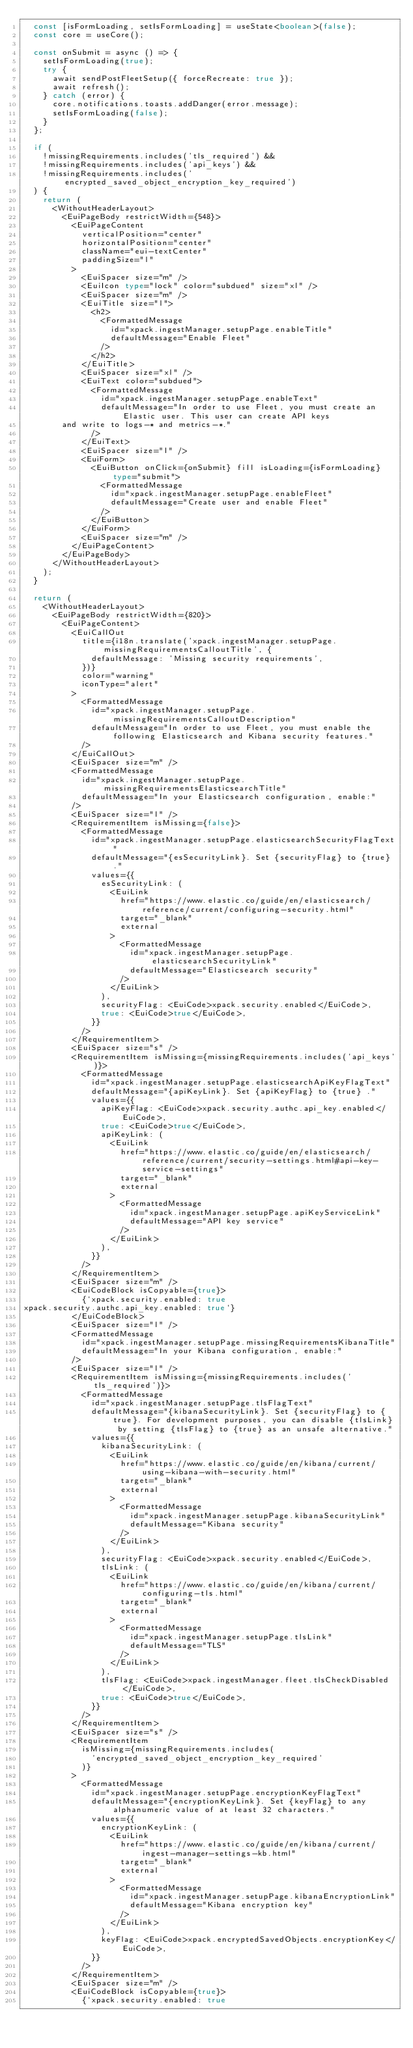<code> <loc_0><loc_0><loc_500><loc_500><_TypeScript_>  const [isFormLoading, setIsFormLoading] = useState<boolean>(false);
  const core = useCore();

  const onSubmit = async () => {
    setIsFormLoading(true);
    try {
      await sendPostFleetSetup({ forceRecreate: true });
      await refresh();
    } catch (error) {
      core.notifications.toasts.addDanger(error.message);
      setIsFormLoading(false);
    }
  };

  if (
    !missingRequirements.includes('tls_required') &&
    !missingRequirements.includes('api_keys') &&
    !missingRequirements.includes('encrypted_saved_object_encryption_key_required')
  ) {
    return (
      <WithoutHeaderLayout>
        <EuiPageBody restrictWidth={548}>
          <EuiPageContent
            verticalPosition="center"
            horizontalPosition="center"
            className="eui-textCenter"
            paddingSize="l"
          >
            <EuiSpacer size="m" />
            <EuiIcon type="lock" color="subdued" size="xl" />
            <EuiSpacer size="m" />
            <EuiTitle size="l">
              <h2>
                <FormattedMessage
                  id="xpack.ingestManager.setupPage.enableTitle"
                  defaultMessage="Enable Fleet"
                />
              </h2>
            </EuiTitle>
            <EuiSpacer size="xl" />
            <EuiText color="subdued">
              <FormattedMessage
                id="xpack.ingestManager.setupPage.enableText"
                defaultMessage="In order to use Fleet, you must create an Elastic user. This user can create API keys
        and write to logs-* and metrics-*."
              />
            </EuiText>
            <EuiSpacer size="l" />
            <EuiForm>
              <EuiButton onClick={onSubmit} fill isLoading={isFormLoading} type="submit">
                <FormattedMessage
                  id="xpack.ingestManager.setupPage.enableFleet"
                  defaultMessage="Create user and enable Fleet"
                />
              </EuiButton>
            </EuiForm>
            <EuiSpacer size="m" />
          </EuiPageContent>
        </EuiPageBody>
      </WithoutHeaderLayout>
    );
  }

  return (
    <WithoutHeaderLayout>
      <EuiPageBody restrictWidth={820}>
        <EuiPageContent>
          <EuiCallOut
            title={i18n.translate('xpack.ingestManager.setupPage.missingRequirementsCalloutTitle', {
              defaultMessage: 'Missing security requirements',
            })}
            color="warning"
            iconType="alert"
          >
            <FormattedMessage
              id="xpack.ingestManager.setupPage.missingRequirementsCalloutDescription"
              defaultMessage="In order to use Fleet, you must enable the following Elasticsearch and Kibana security features."
            />
          </EuiCallOut>
          <EuiSpacer size="m" />
          <FormattedMessage
            id="xpack.ingestManager.setupPage.missingRequirementsElasticsearchTitle"
            defaultMessage="In your Elasticsearch configuration, enable:"
          />
          <EuiSpacer size="l" />
          <RequirementItem isMissing={false}>
            <FormattedMessage
              id="xpack.ingestManager.setupPage.elasticsearchSecurityFlagText"
              defaultMessage="{esSecurityLink}. Set {securityFlag} to {true} ."
              values={{
                esSecurityLink: (
                  <EuiLink
                    href="https://www.elastic.co/guide/en/elasticsearch/reference/current/configuring-security.html"
                    target="_blank"
                    external
                  >
                    <FormattedMessage
                      id="xpack.ingestManager.setupPage.elasticsearchSecurityLink"
                      defaultMessage="Elasticsearch security"
                    />
                  </EuiLink>
                ),
                securityFlag: <EuiCode>xpack.security.enabled</EuiCode>,
                true: <EuiCode>true</EuiCode>,
              }}
            />
          </RequirementItem>
          <EuiSpacer size="s" />
          <RequirementItem isMissing={missingRequirements.includes('api_keys')}>
            <FormattedMessage
              id="xpack.ingestManager.setupPage.elasticsearchApiKeyFlagText"
              defaultMessage="{apiKeyLink}. Set {apiKeyFlag} to {true} ."
              values={{
                apiKeyFlag: <EuiCode>xpack.security.authc.api_key.enabled</EuiCode>,
                true: <EuiCode>true</EuiCode>,
                apiKeyLink: (
                  <EuiLink
                    href="https://www.elastic.co/guide/en/elasticsearch/reference/current/security-settings.html#api-key-service-settings"
                    target="_blank"
                    external
                  >
                    <FormattedMessage
                      id="xpack.ingestManager.setupPage.apiKeyServiceLink"
                      defaultMessage="API key service"
                    />
                  </EuiLink>
                ),
              }}
            />
          </RequirementItem>
          <EuiSpacer size="m" />
          <EuiCodeBlock isCopyable={true}>
            {`xpack.security.enabled: true
xpack.security.authc.api_key.enabled: true`}
          </EuiCodeBlock>
          <EuiSpacer size="l" />
          <FormattedMessage
            id="xpack.ingestManager.setupPage.missingRequirementsKibanaTitle"
            defaultMessage="In your Kibana configuration, enable:"
          />
          <EuiSpacer size="l" />
          <RequirementItem isMissing={missingRequirements.includes('tls_required')}>
            <FormattedMessage
              id="xpack.ingestManager.setupPage.tlsFlagText"
              defaultMessage="{kibanaSecurityLink}. Set {securityFlag} to {true}. For development purposes, you can disable {tlsLink} by setting {tlsFlag} to {true} as an unsafe alternative."
              values={{
                kibanaSecurityLink: (
                  <EuiLink
                    href="https://www.elastic.co/guide/en/kibana/current/using-kibana-with-security.html"
                    target="_blank"
                    external
                  >
                    <FormattedMessage
                      id="xpack.ingestManager.setupPage.kibanaSecurityLink"
                      defaultMessage="Kibana security"
                    />
                  </EuiLink>
                ),
                securityFlag: <EuiCode>xpack.security.enabled</EuiCode>,
                tlsLink: (
                  <EuiLink
                    href="https://www.elastic.co/guide/en/kibana/current/configuring-tls.html"
                    target="_blank"
                    external
                  >
                    <FormattedMessage
                      id="xpack.ingestManager.setupPage.tlsLink"
                      defaultMessage="TLS"
                    />
                  </EuiLink>
                ),
                tlsFlag: <EuiCode>xpack.ingestManager.fleet.tlsCheckDisabled</EuiCode>,
                true: <EuiCode>true</EuiCode>,
              }}
            />
          </RequirementItem>
          <EuiSpacer size="s" />
          <RequirementItem
            isMissing={missingRequirements.includes(
              'encrypted_saved_object_encryption_key_required'
            )}
          >
            <FormattedMessage
              id="xpack.ingestManager.setupPage.encryptionKeyFlagText"
              defaultMessage="{encryptionKeyLink}. Set {keyFlag} to any alphanumeric value of at least 32 characters."
              values={{
                encryptionKeyLink: (
                  <EuiLink
                    href="https://www.elastic.co/guide/en/kibana/current/ingest-manager-settings-kb.html"
                    target="_blank"
                    external
                  >
                    <FormattedMessage
                      id="xpack.ingestManager.setupPage.kibanaEncryptionLink"
                      defaultMessage="Kibana encryption key"
                    />
                  </EuiLink>
                ),
                keyFlag: <EuiCode>xpack.encryptedSavedObjects.encryptionKey</EuiCode>,
              }}
            />
          </RequirementItem>
          <EuiSpacer size="m" />
          <EuiCodeBlock isCopyable={true}>
            {`xpack.security.enabled: true</code> 